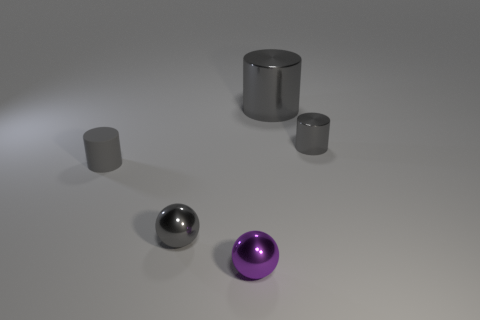There is a small matte thing that is the same color as the big shiny cylinder; what is its shape?
Give a very brief answer. Cylinder. How many shiny objects are small spheres or big cylinders?
Ensure brevity in your answer.  3. What is the shape of the tiny gray object that is right of the large gray cylinder?
Give a very brief answer. Cylinder. What is the shape of the shiny object that is behind the tiny gray sphere and in front of the big gray cylinder?
Provide a succinct answer. Cylinder. There is a small ball right of the gray metallic sphere; does it have the same color as the big metal cylinder?
Provide a succinct answer. No. Does the small gray metal thing that is to the right of the tiny gray sphere have the same shape as the big gray metallic thing to the right of the purple shiny object?
Offer a very short reply. Yes. What is the size of the metallic object behind the small gray shiny cylinder?
Your answer should be very brief. Large. What is the size of the metal cylinder that is behind the small gray cylinder that is on the right side of the gray rubber cylinder?
Ensure brevity in your answer.  Large. Is the number of gray spheres greater than the number of small gray metal things?
Give a very brief answer. No. Is the number of large gray shiny cylinders that are behind the tiny matte cylinder greater than the number of small purple things behind the small purple thing?
Your answer should be very brief. Yes. 